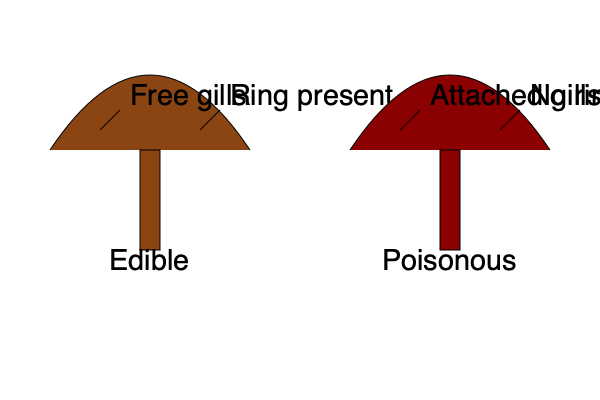Based on the illustrated characteristics, which of the following statements is most accurate for distinguishing between the edible and poisonous mushrooms shown?

A) Edible mushrooms always have free gills and a ring, while poisonous mushrooms have attached gills and no ring.
B) The presence of a ring is the only reliable indicator of an edible mushroom.
C) Gill attachment and the presence of a ring can be useful indicators, but are not definitive in determining edibility.
D) Poisonous mushrooms always have a red cap, while edible mushrooms have a brown cap. To answer this question, let's analyze the characteristics shown in the illustration and consider the complexities of mushroom identification:

1. Gill attachment:
   - The edible mushroom is shown with free gills.
   - The poisonous mushroom is shown with attached gills.

2. Presence of a ring:
   - The edible mushroom is shown with a ring present.
   - The poisonous mushroom is shown without a ring.

3. Cap color:
   - The edible mushroom has a brown cap.
   - The poisonous mushroom has a red cap.

However, it's crucial to understand that these characteristics are not universal rules for determining edibility:

4. Variability in mushroom features:
   - Some edible mushrooms may have attached gills or lack a ring.
   - Some poisonous mushrooms may have free gills or possess a ring.
   - Cap color can vary widely among both edible and poisonous species.

5. Complexity of mushroom taxonomy:
   - Mushroom identification often requires consideration of multiple features, including spore print, habitat, and microscopic characteristics.
   - Some lookalike species can share similar macroscopic features but differ in edibility.

6. Limitations of visual identification:
   - Relying solely on visual characteristics can be dangerous, as some toxic species closely resemble edible ones.

Given these considerations, the most accurate statement is option C. While gill attachment and the presence of a ring can be useful indicators in mushroom identification, they are not definitive in determining edibility. Other factors must be considered, and expert knowledge is often necessary for safe mushroom foraging.
Answer: C) Gill attachment and the presence of a ring can be useful indicators, but are not definitive in determining edibility. 